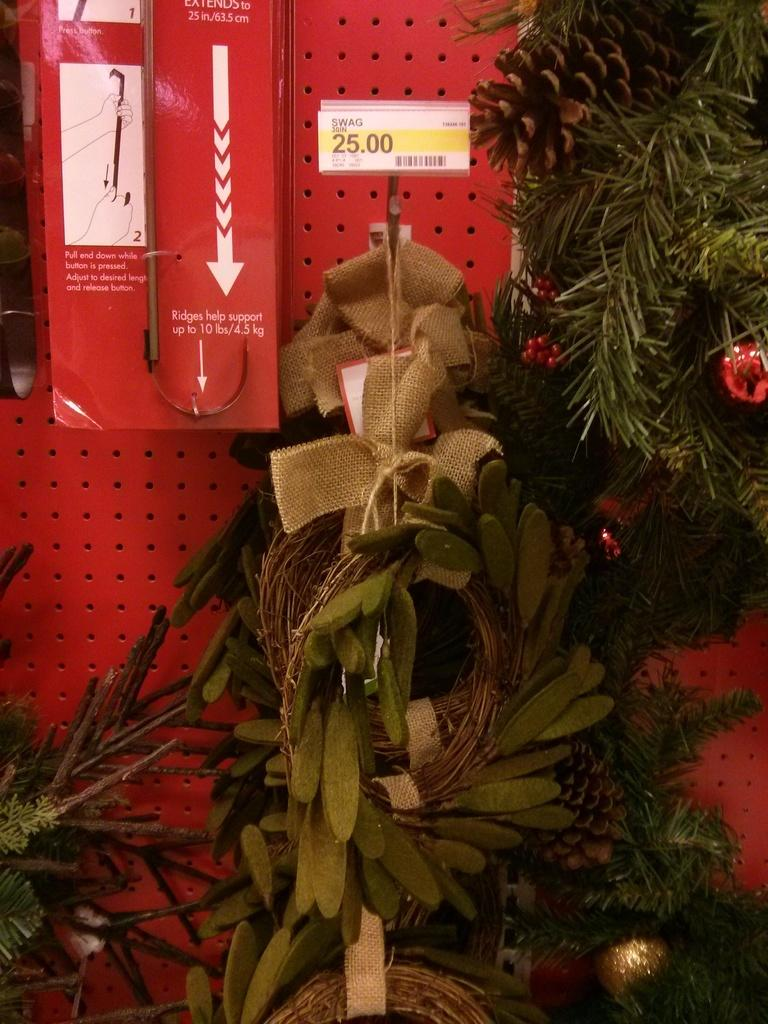What type of living organisms can be seen in the image? Plants can be seen in the image. What is located behind the plants? There is a wall behind the plants. Is there any object attached to the wall? Yes, there is a box on the wall. What type of chair can be seen in the image? There is no chair present in the image. Is there any indication of an airport in the image? There is no indication of an airport in the image. 